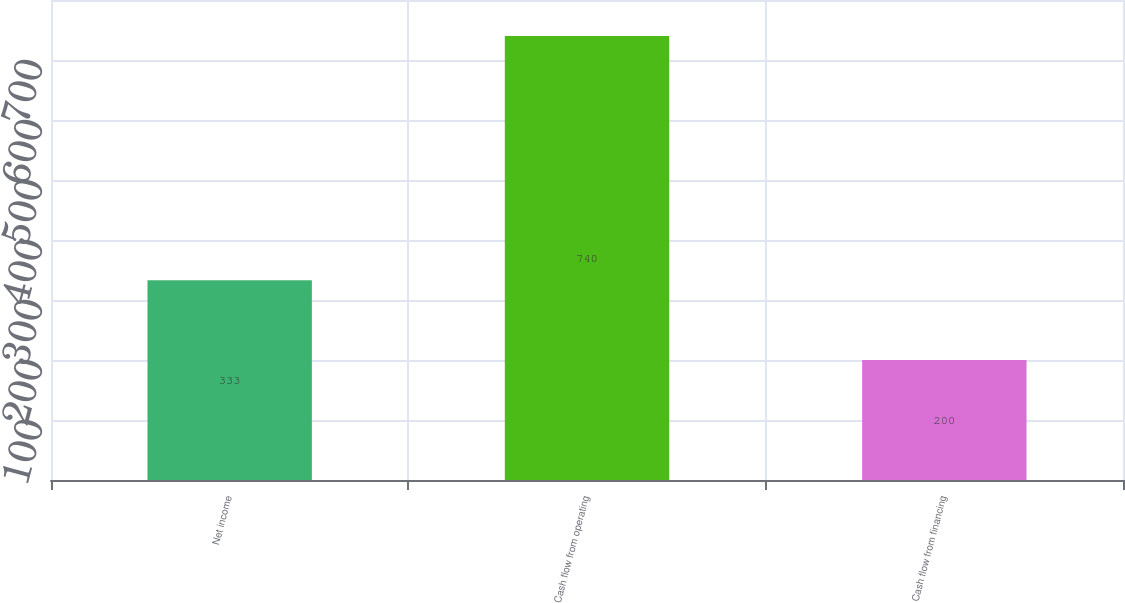<chart> <loc_0><loc_0><loc_500><loc_500><bar_chart><fcel>Net income<fcel>Cash flow from operating<fcel>Cash flow from financing<nl><fcel>333<fcel>740<fcel>200<nl></chart> 